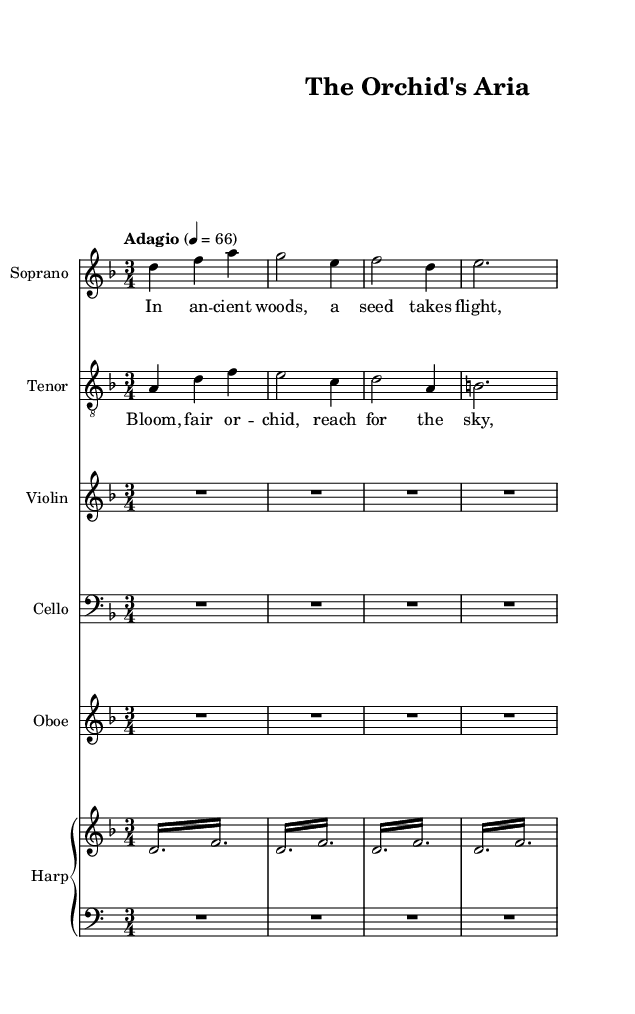What is the key signature of this music? The key signature is indicated in the global section of the score with the command "\key d \minor," which shows that this piece is in the key of D minor.
Answer: D minor What is the time signature of this music? The time signature is also indicated in the global section with the command "\time 3/4," meaning there are three beats in each measure and a quarter note receives one beat.
Answer: 3/4 What tempo marking is given for this piece? The tempo marking is specified in the global section with "\tempo 'Adagio' 4 = 66," indicating a slow tempo, which is typical for the Adagio style.
Answer: Adagio How many measures are in the soprano part? The soprano part shows four measures with distinct note groupings. By counting the vertical lines indicating the end of each measure, the total reaches four.
Answer: 4 Which instrument has a rest for the entire section? In the provided score, both the violin and cello parts contain "R2.*4," which indicates they rest for the entire section, as no notes are played.
Answer: Violin and Cello What is the theme of the first verse's lyrics? The first verse lyrics, "In an -- cient woods, a seed takes flight, Nes -- tled in moss, a -- wait -- ing light," describe the planting and initial growth of an orchid seed, conveying themes of nature and anticipation.
Answer: Growth of an orchid seed What is the primary emotion conveyed through the chorus lyrics? The chorus lyrics, "Bloom, fair or -- chid, reach for the sky, Na -- ture's beau -- ty, nev -- er to die," express a hopeful and celebratory emotion, highlighting the beauty of nature and the persistence of life.
Answer: Hopeful and celebratory 